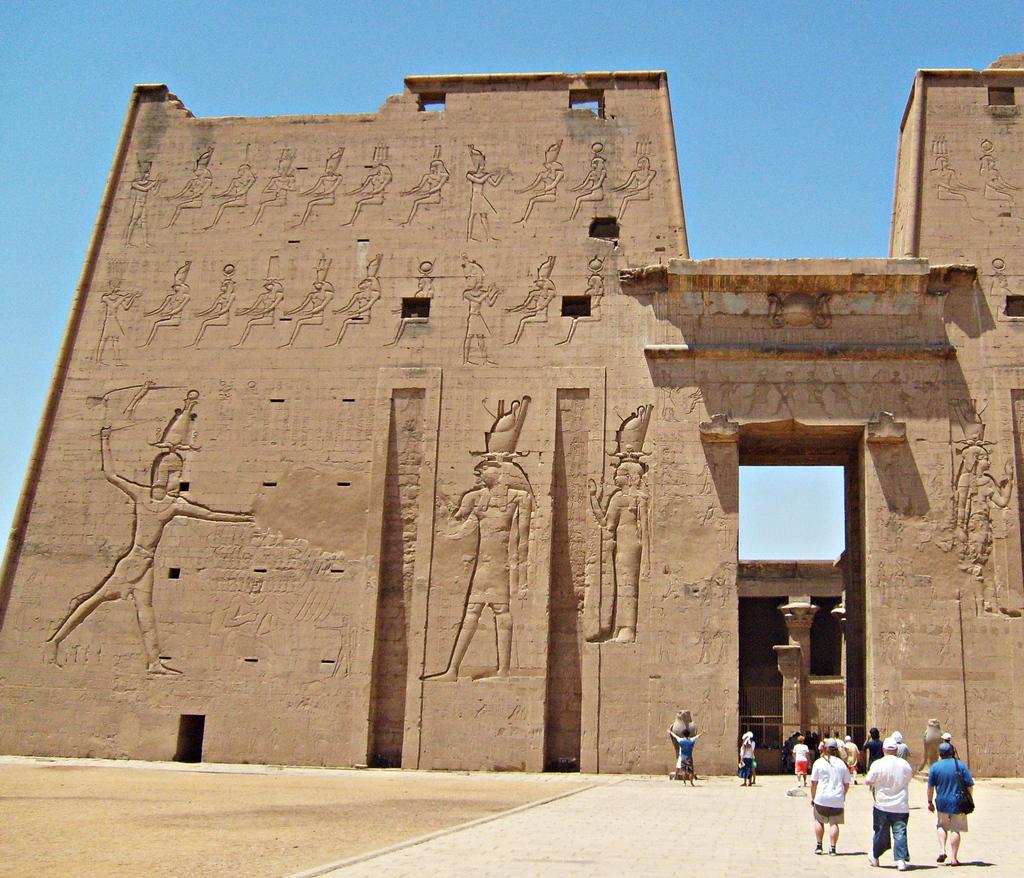In one or two sentences, can you explain what this image depicts? In the foreground of the picture there are people walking on a pavement. In the center of the picture there is a monument, on the monument there are sculptures. In the background it is sky, sky is sunny. On the left it is soil. 